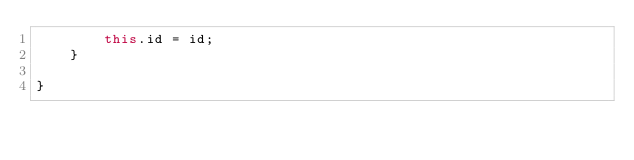Convert code to text. <code><loc_0><loc_0><loc_500><loc_500><_Java_>        this.id = id;
    }

}
</code> 